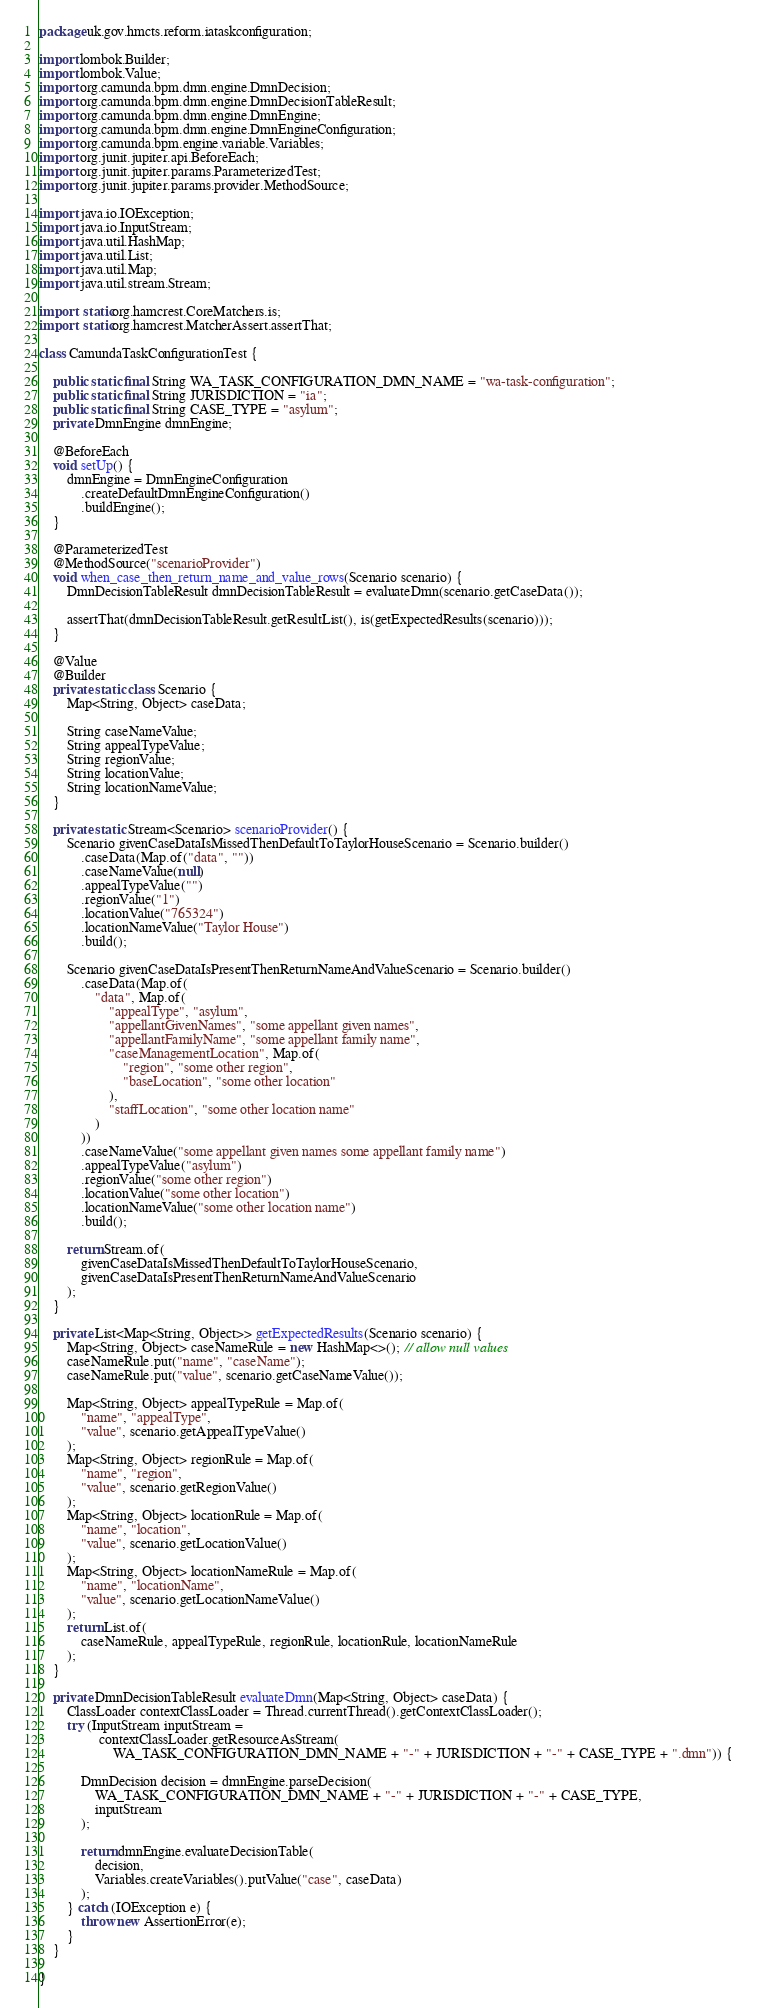Convert code to text. <code><loc_0><loc_0><loc_500><loc_500><_Java_>package uk.gov.hmcts.reform.iataskconfiguration;

import lombok.Builder;
import lombok.Value;
import org.camunda.bpm.dmn.engine.DmnDecision;
import org.camunda.bpm.dmn.engine.DmnDecisionTableResult;
import org.camunda.bpm.dmn.engine.DmnEngine;
import org.camunda.bpm.dmn.engine.DmnEngineConfiguration;
import org.camunda.bpm.engine.variable.Variables;
import org.junit.jupiter.api.BeforeEach;
import org.junit.jupiter.params.ParameterizedTest;
import org.junit.jupiter.params.provider.MethodSource;

import java.io.IOException;
import java.io.InputStream;
import java.util.HashMap;
import java.util.List;
import java.util.Map;
import java.util.stream.Stream;

import static org.hamcrest.CoreMatchers.is;
import static org.hamcrest.MatcherAssert.assertThat;

class CamundaTaskConfigurationTest {

    public static final String WA_TASK_CONFIGURATION_DMN_NAME = "wa-task-configuration";
    public static final String JURISDICTION = "ia";
    public static final String CASE_TYPE = "asylum";
    private DmnEngine dmnEngine;

    @BeforeEach
    void setUp() {
        dmnEngine = DmnEngineConfiguration
            .createDefaultDmnEngineConfiguration()
            .buildEngine();
    }

    @ParameterizedTest
    @MethodSource("scenarioProvider")
    void when_case_then_return_name_and_value_rows(Scenario scenario) {
        DmnDecisionTableResult dmnDecisionTableResult = evaluateDmn(scenario.getCaseData());

        assertThat(dmnDecisionTableResult.getResultList(), is(getExpectedResults(scenario)));
    }

    @Value
    @Builder
    private static class Scenario {
        Map<String, Object> caseData;

        String caseNameValue;
        String appealTypeValue;
        String regionValue;
        String locationValue;
        String locationNameValue;
    }

    private static Stream<Scenario> scenarioProvider() {
        Scenario givenCaseDataIsMissedThenDefaultToTaylorHouseScenario = Scenario.builder()
            .caseData(Map.of("data", ""))
            .caseNameValue(null)
            .appealTypeValue("")
            .regionValue("1")
            .locationValue("765324")
            .locationNameValue("Taylor House")
            .build();

        Scenario givenCaseDataIsPresentThenReturnNameAndValueScenario = Scenario.builder()
            .caseData(Map.of(
                "data", Map.of(
                    "appealType", "asylum",
                    "appellantGivenNames", "some appellant given names",
                    "appellantFamilyName", "some appellant family name",
                    "caseManagementLocation", Map.of(
                        "region", "some other region",
                        "baseLocation", "some other location"
                    ),
                    "staffLocation", "some other location name"
                )
            ))
            .caseNameValue("some appellant given names some appellant family name")
            .appealTypeValue("asylum")
            .regionValue("some other region")
            .locationValue("some other location")
            .locationNameValue("some other location name")
            .build();

        return Stream.of(
            givenCaseDataIsMissedThenDefaultToTaylorHouseScenario,
            givenCaseDataIsPresentThenReturnNameAndValueScenario
        );
    }

    private List<Map<String, Object>> getExpectedResults(Scenario scenario) {
        Map<String, Object> caseNameRule = new HashMap<>(); // allow null values
        caseNameRule.put("name", "caseName");
        caseNameRule.put("value", scenario.getCaseNameValue());

        Map<String, Object> appealTypeRule = Map.of(
            "name", "appealType",
            "value", scenario.getAppealTypeValue()
        );
        Map<String, Object> regionRule = Map.of(
            "name", "region",
            "value", scenario.getRegionValue()
        );
        Map<String, Object> locationRule = Map.of(
            "name", "location",
            "value", scenario.getLocationValue()
        );
        Map<String, Object> locationNameRule = Map.of(
            "name", "locationName",
            "value", scenario.getLocationNameValue()
        );
        return List.of(
            caseNameRule, appealTypeRule, regionRule, locationRule, locationNameRule
        );
    }

    private DmnDecisionTableResult evaluateDmn(Map<String, Object> caseData) {
        ClassLoader contextClassLoader = Thread.currentThread().getContextClassLoader();
        try (InputStream inputStream =
                 contextClassLoader.getResourceAsStream(
                     WA_TASK_CONFIGURATION_DMN_NAME + "-" + JURISDICTION + "-" + CASE_TYPE + ".dmn")) {

            DmnDecision decision = dmnEngine.parseDecision(
                WA_TASK_CONFIGURATION_DMN_NAME + "-" + JURISDICTION + "-" + CASE_TYPE,
                inputStream
            );

            return dmnEngine.evaluateDecisionTable(
                decision,
                Variables.createVariables().putValue("case", caseData)
            );
        } catch (IOException e) {
            throw new AssertionError(e);
        }
    }

}
</code> 